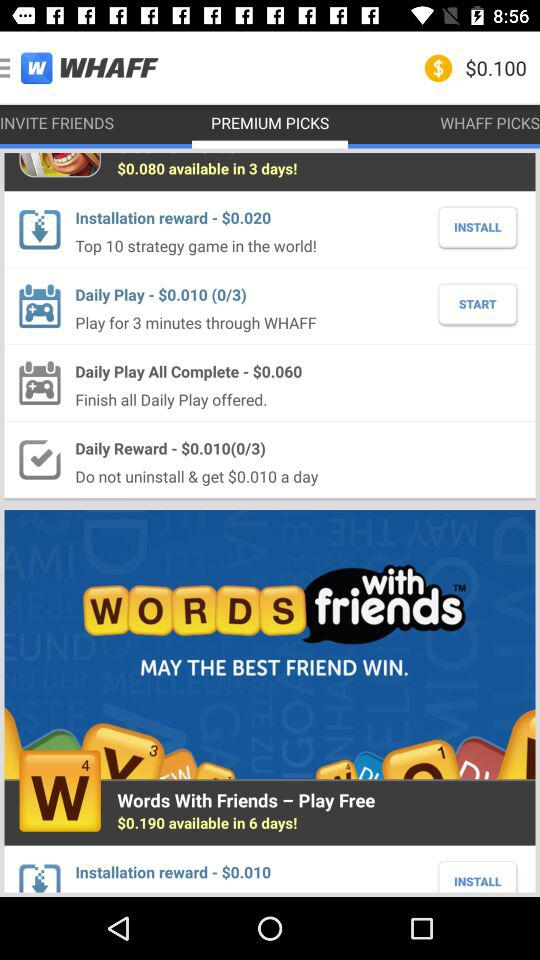How many minutes do we need to play through "WHAFF" in the daily play category? You need to play for 3 minutes through "WHAFF". 